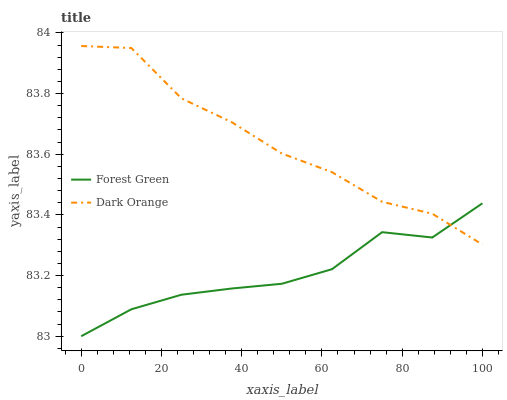Does Forest Green have the minimum area under the curve?
Answer yes or no. Yes. Does Dark Orange have the maximum area under the curve?
Answer yes or no. Yes. Does Forest Green have the maximum area under the curve?
Answer yes or no. No. Is Forest Green the smoothest?
Answer yes or no. Yes. Is Dark Orange the roughest?
Answer yes or no. Yes. Is Forest Green the roughest?
Answer yes or no. No. Does Forest Green have the lowest value?
Answer yes or no. Yes. Does Dark Orange have the highest value?
Answer yes or no. Yes. Does Forest Green have the highest value?
Answer yes or no. No. Does Dark Orange intersect Forest Green?
Answer yes or no. Yes. Is Dark Orange less than Forest Green?
Answer yes or no. No. Is Dark Orange greater than Forest Green?
Answer yes or no. No. 